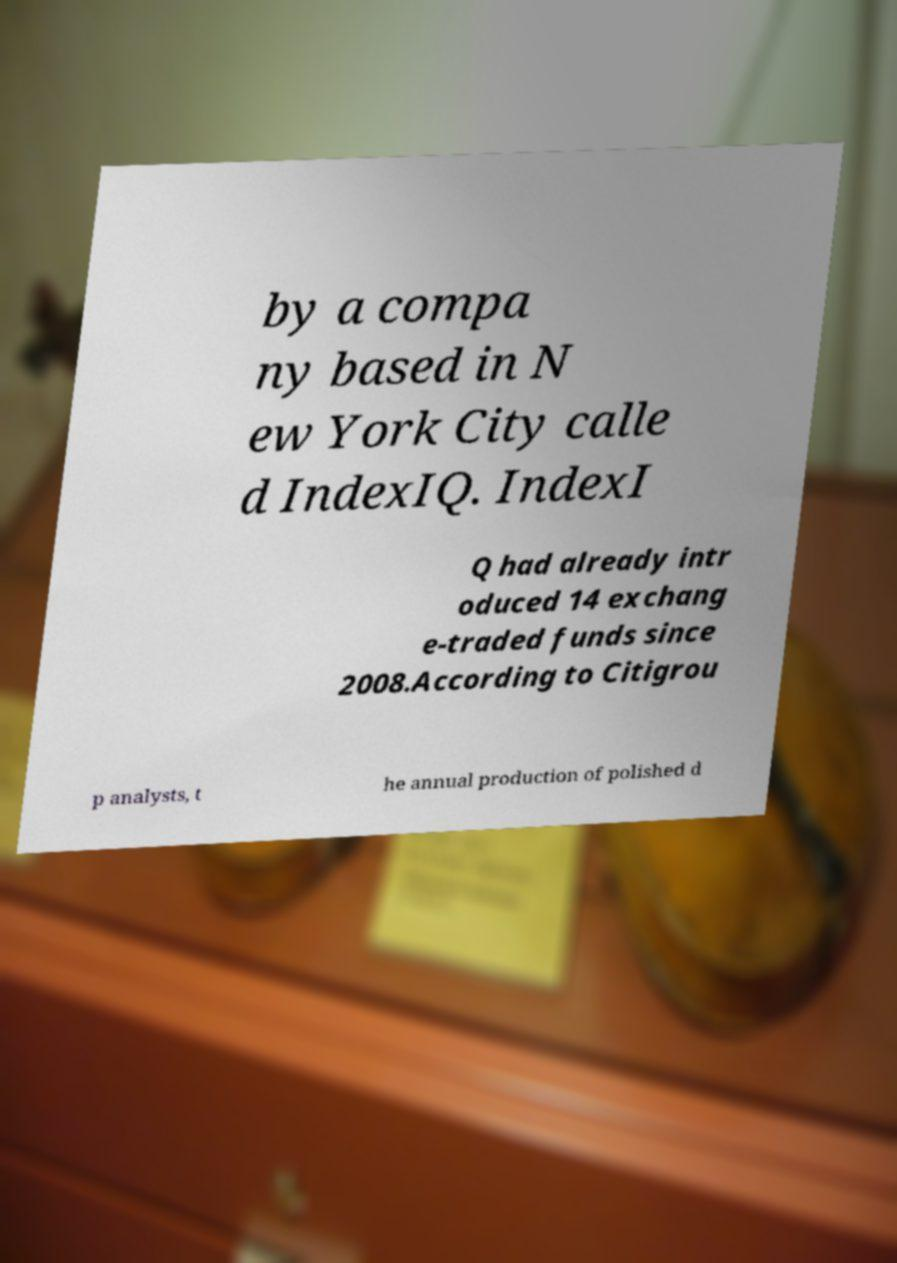Please identify and transcribe the text found in this image. by a compa ny based in N ew York City calle d IndexIQ. IndexI Q had already intr oduced 14 exchang e-traded funds since 2008.According to Citigrou p analysts, t he annual production of polished d 